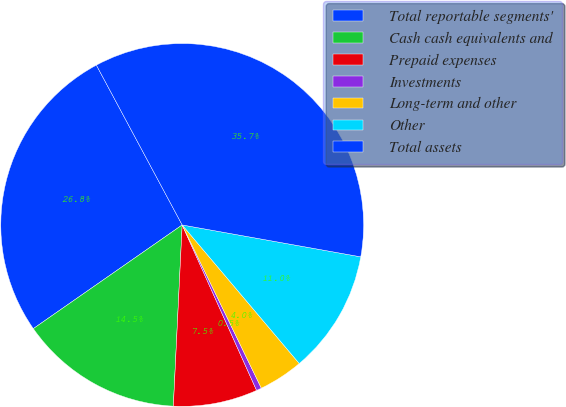Convert chart. <chart><loc_0><loc_0><loc_500><loc_500><pie_chart><fcel>Total reportable segments'<fcel>Cash cash equivalents and<fcel>Prepaid expenses<fcel>Investments<fcel>Long-term and other<fcel>Other<fcel>Total assets<nl><fcel>26.84%<fcel>14.54%<fcel>7.5%<fcel>0.46%<fcel>3.98%<fcel>11.02%<fcel>35.65%<nl></chart> 